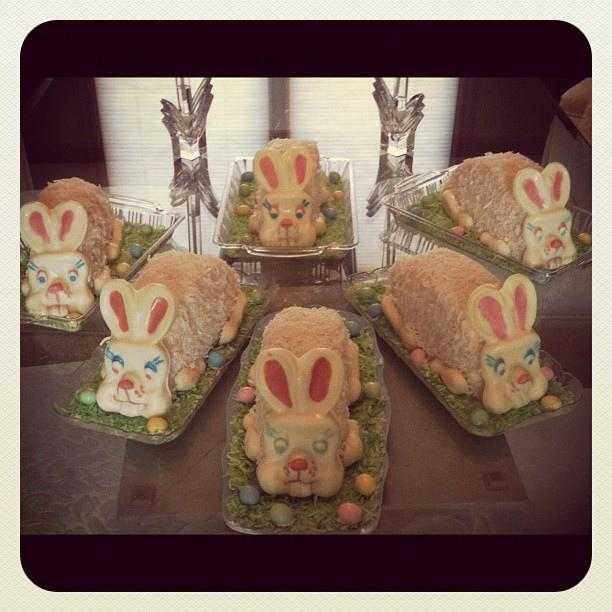What kind of animals are these cakes prepared to the shape of?

Choices:
A) fox
B) hound
C) rabbit
D) penguin rabbit 